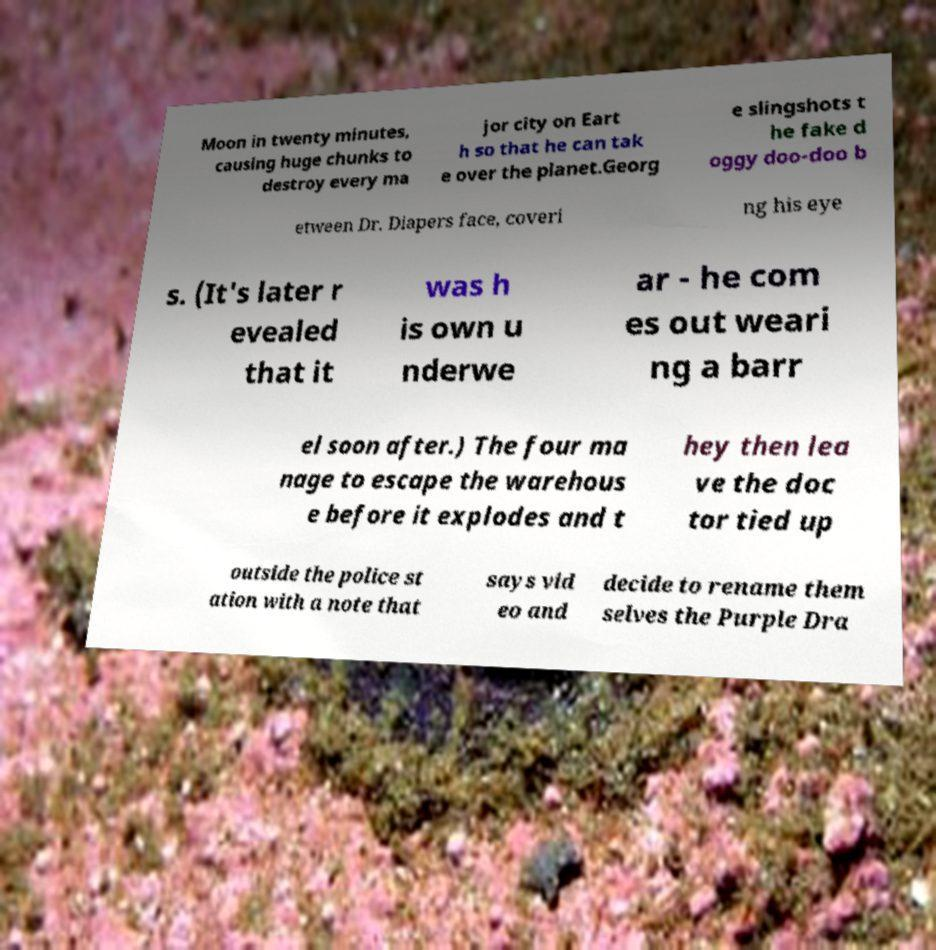Please read and relay the text visible in this image. What does it say? Moon in twenty minutes, causing huge chunks to destroy every ma jor city on Eart h so that he can tak e over the planet.Georg e slingshots t he fake d oggy doo-doo b etween Dr. Diapers face, coveri ng his eye s. (It's later r evealed that it was h is own u nderwe ar - he com es out weari ng a barr el soon after.) The four ma nage to escape the warehous e before it explodes and t hey then lea ve the doc tor tied up outside the police st ation with a note that says vid eo and decide to rename them selves the Purple Dra 